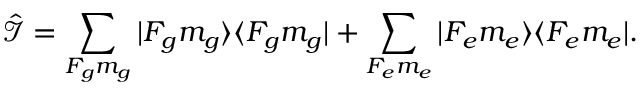Convert formula to latex. <formula><loc_0><loc_0><loc_500><loc_500>\hat { \mathcal { I } } = \sum _ { F _ { g } m _ { g } } | F _ { g } m _ { g } \rangle \langle F _ { g } m _ { g } | + \sum _ { F _ { e } m _ { e } } | F _ { e } m _ { e } \rangle \langle F _ { e } m _ { e } | .</formula> 